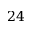Convert formula to latex. <formula><loc_0><loc_0><loc_500><loc_500>2 4</formula> 